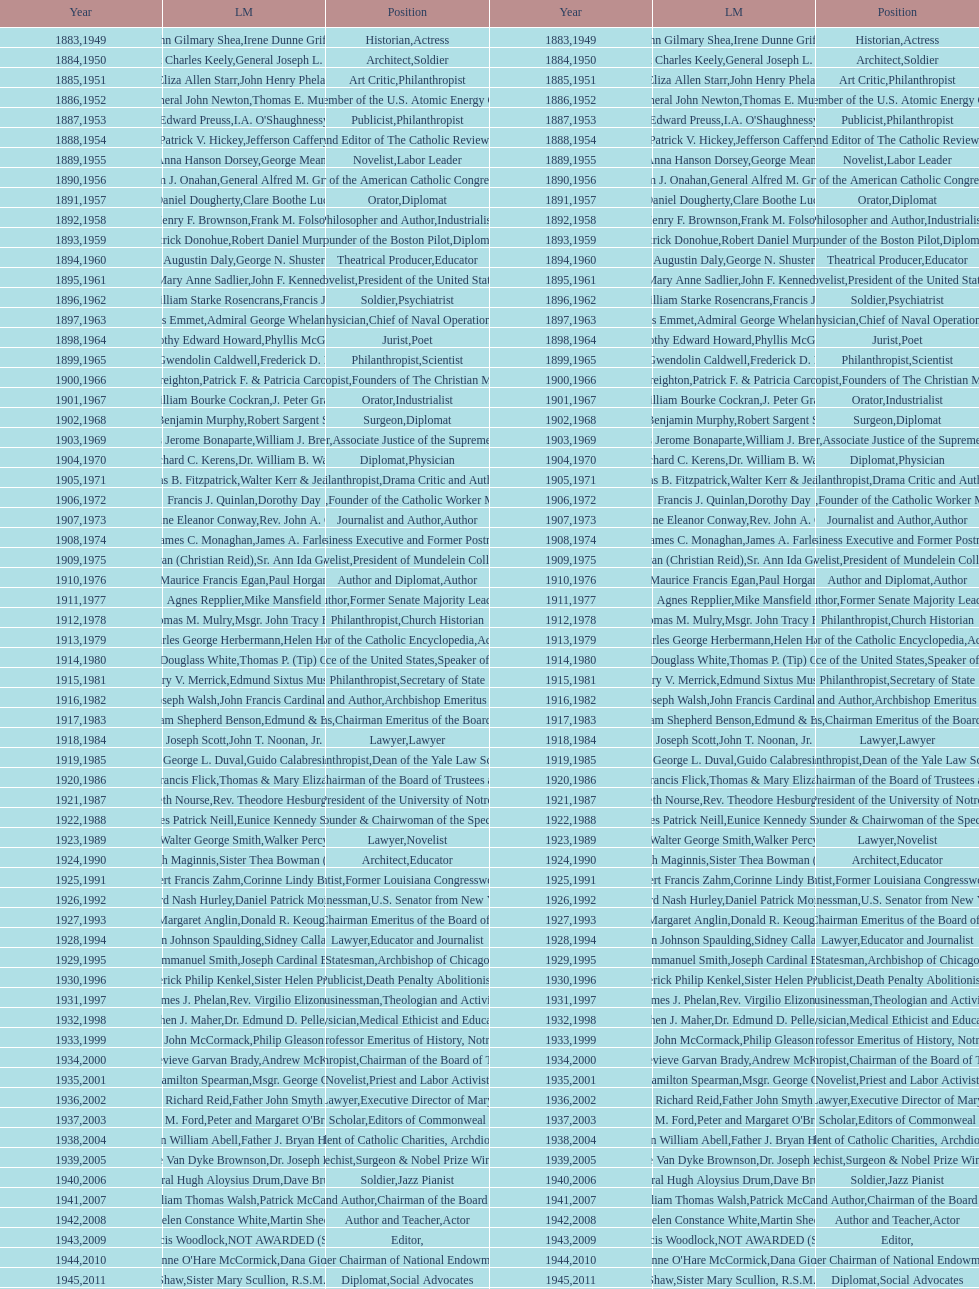Who has received this medal in addition to the nobel prize? Dr. Joseph E. Murray. 